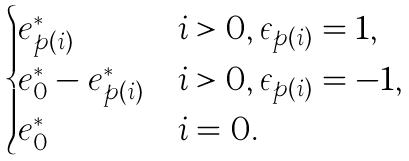<formula> <loc_0><loc_0><loc_500><loc_500>\begin{cases} e _ { p ( i ) } ^ { * } & i > 0 , \epsilon _ { p ( i ) } = 1 , \\ e _ { 0 } ^ { * } - e _ { p ( i ) } ^ { * } & i > 0 , \epsilon _ { p ( i ) } = - 1 , \\ e _ { 0 } ^ { * } & i = 0 . \end{cases}</formula> 